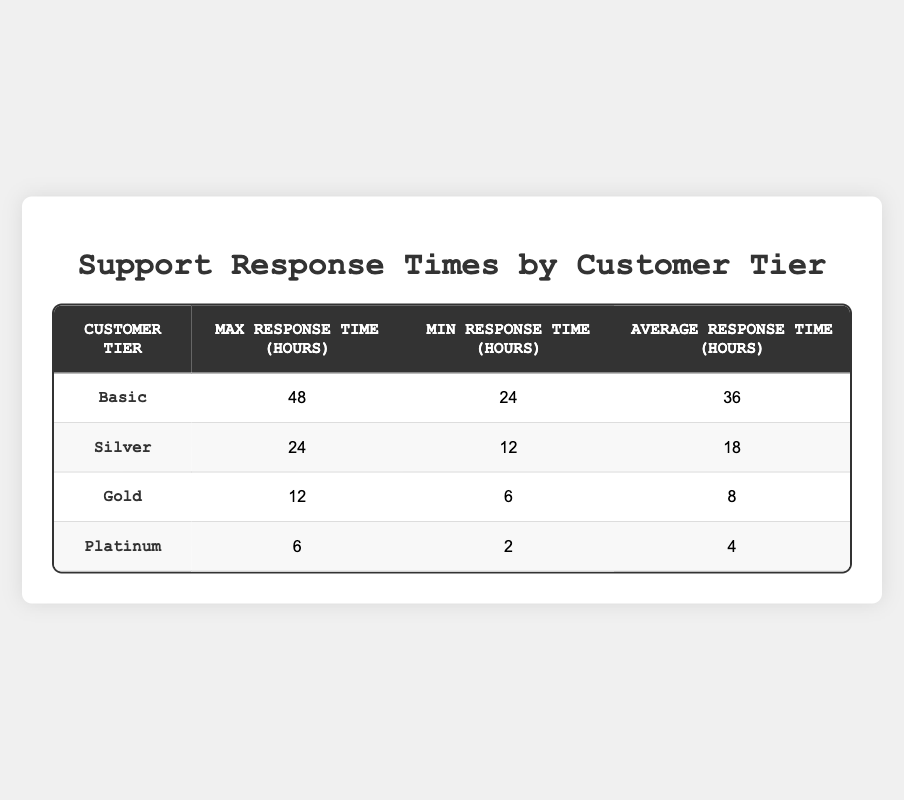What is the average response time for the Basic customer tier? The table shows that the average response time for the Basic tier is listed under the "Average Response Time" column. By reading the table, we find that this value is 36 hours.
Answer: 36 hours Which customer tier has the maximum response time? Looking at the "Max Response Time" column for each customer tier, the Basic tier has the highest maximum response time of 48 hours, while the remaining tiers have lower values.
Answer: Basic What is the difference in average response time between Basic and Gold tiers? The average response time for Basic is 36 hours, and for Gold, it is 8 hours. To find the difference, we subtract 8 from 36: 36 - 8 = 28 hours.
Answer: 28 hours Is the minimum response time for the Silver tier greater than the average response time for the Platinum tier? The minimum response time for Silver is 12 hours, and the average response time for Platinum is 4 hours. Since 12 is greater than 4, the statement is true.
Answer: Yes What is the average maximum response time across all customer tiers? To calculate this, we sum the maximum response times: 48 + 24 + 12 + 6 = 90 hours. There are 4 customer tiers, so we divide by 4: 90 / 4 = 22.5 hours.
Answer: 22.5 hours What is the minimum response time for the Gold tier? The table provides the specific minimum response time for the Gold tier, which is directly listed as 6 hours.
Answer: 6 hours Do the Platinum tier customers have lower average response times than Silver tier customers? The average response time for Platinum is 4 hours, while for Silver, it is 18 hours. Since 4 is less than 18, the statement is true.
Answer: Yes What is the combined maximum response time of Gold and Platinum tiers? The maximum response times for Gold and Platinum tiers are 12 hours and 6 hours, respectively. Adding these together gives us 12 + 6 = 18 hours.
Answer: 18 hours What are the average response times for all customer tiers, from Basic to Platinum, in descending order? The average response times are 36 hours (Basic), 18 hours (Silver), 8 hours (Gold), and 4 hours (Platinum). Arranging these in descending order gives: 36, 18, 8, 4.
Answer: 36, 18, 8, 4 